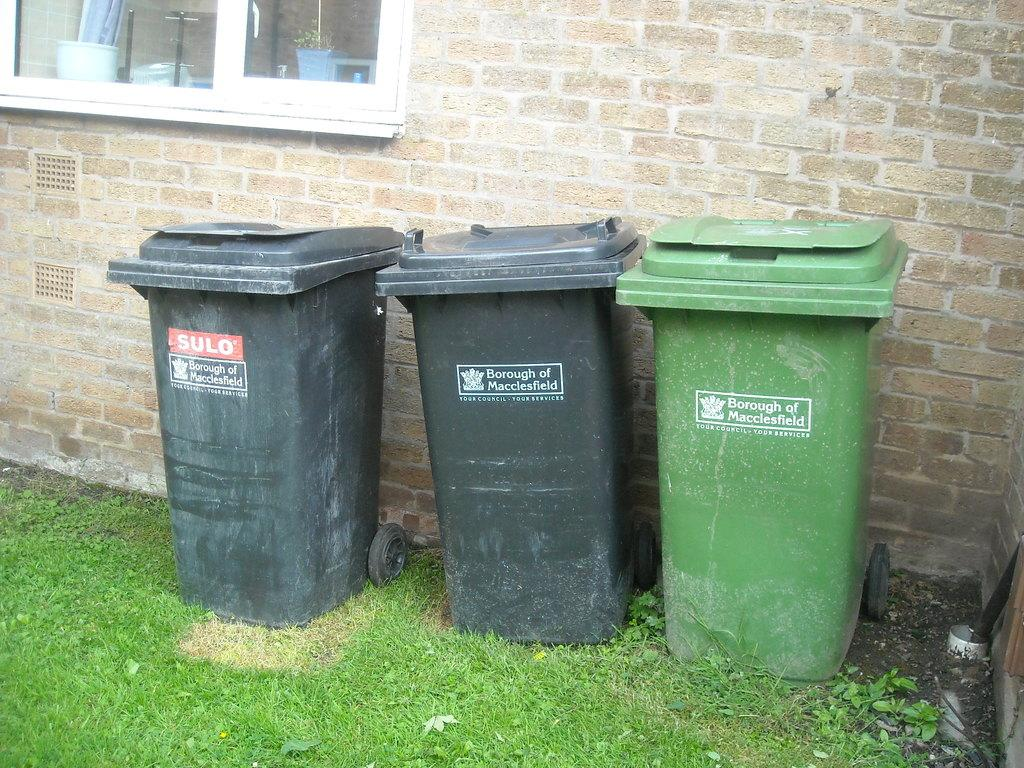Provide a one-sentence caption for the provided image. Three trash bins, all are marked Borough of Macclesfield. 